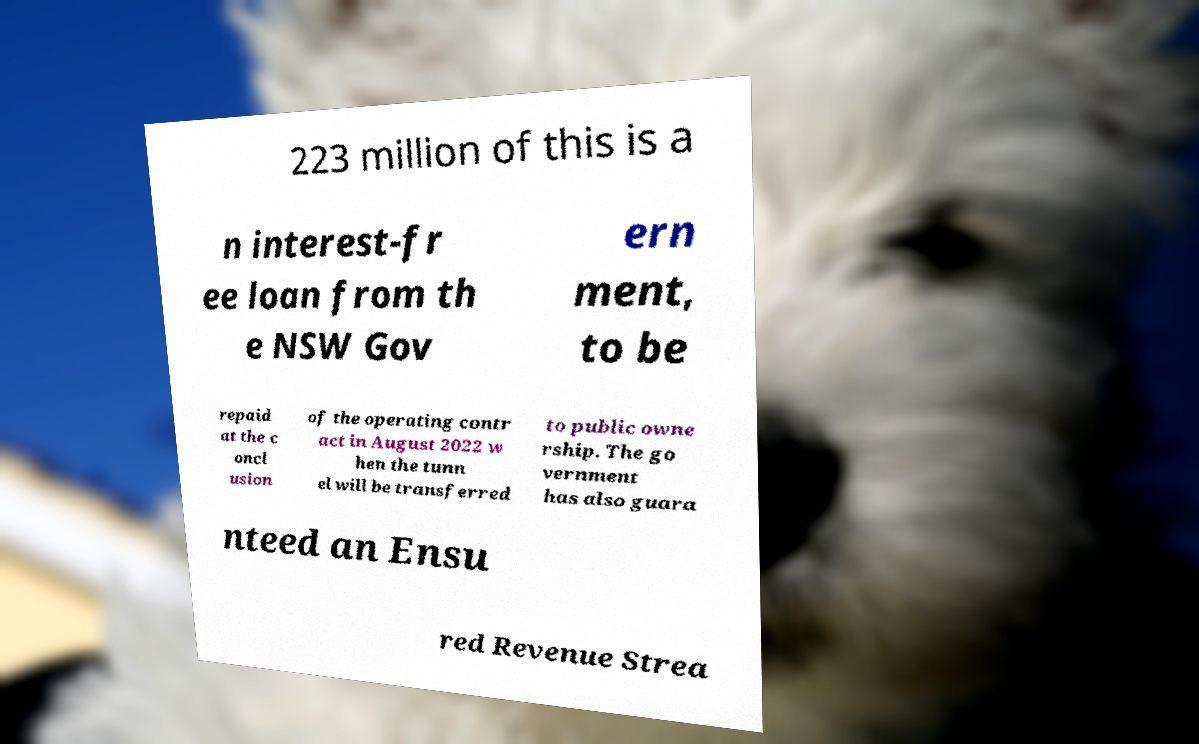For documentation purposes, I need the text within this image transcribed. Could you provide that? 223 million of this is a n interest-fr ee loan from th e NSW Gov ern ment, to be repaid at the c oncl usion of the operating contr act in August 2022 w hen the tunn el will be transferred to public owne rship. The go vernment has also guara nteed an Ensu red Revenue Strea 